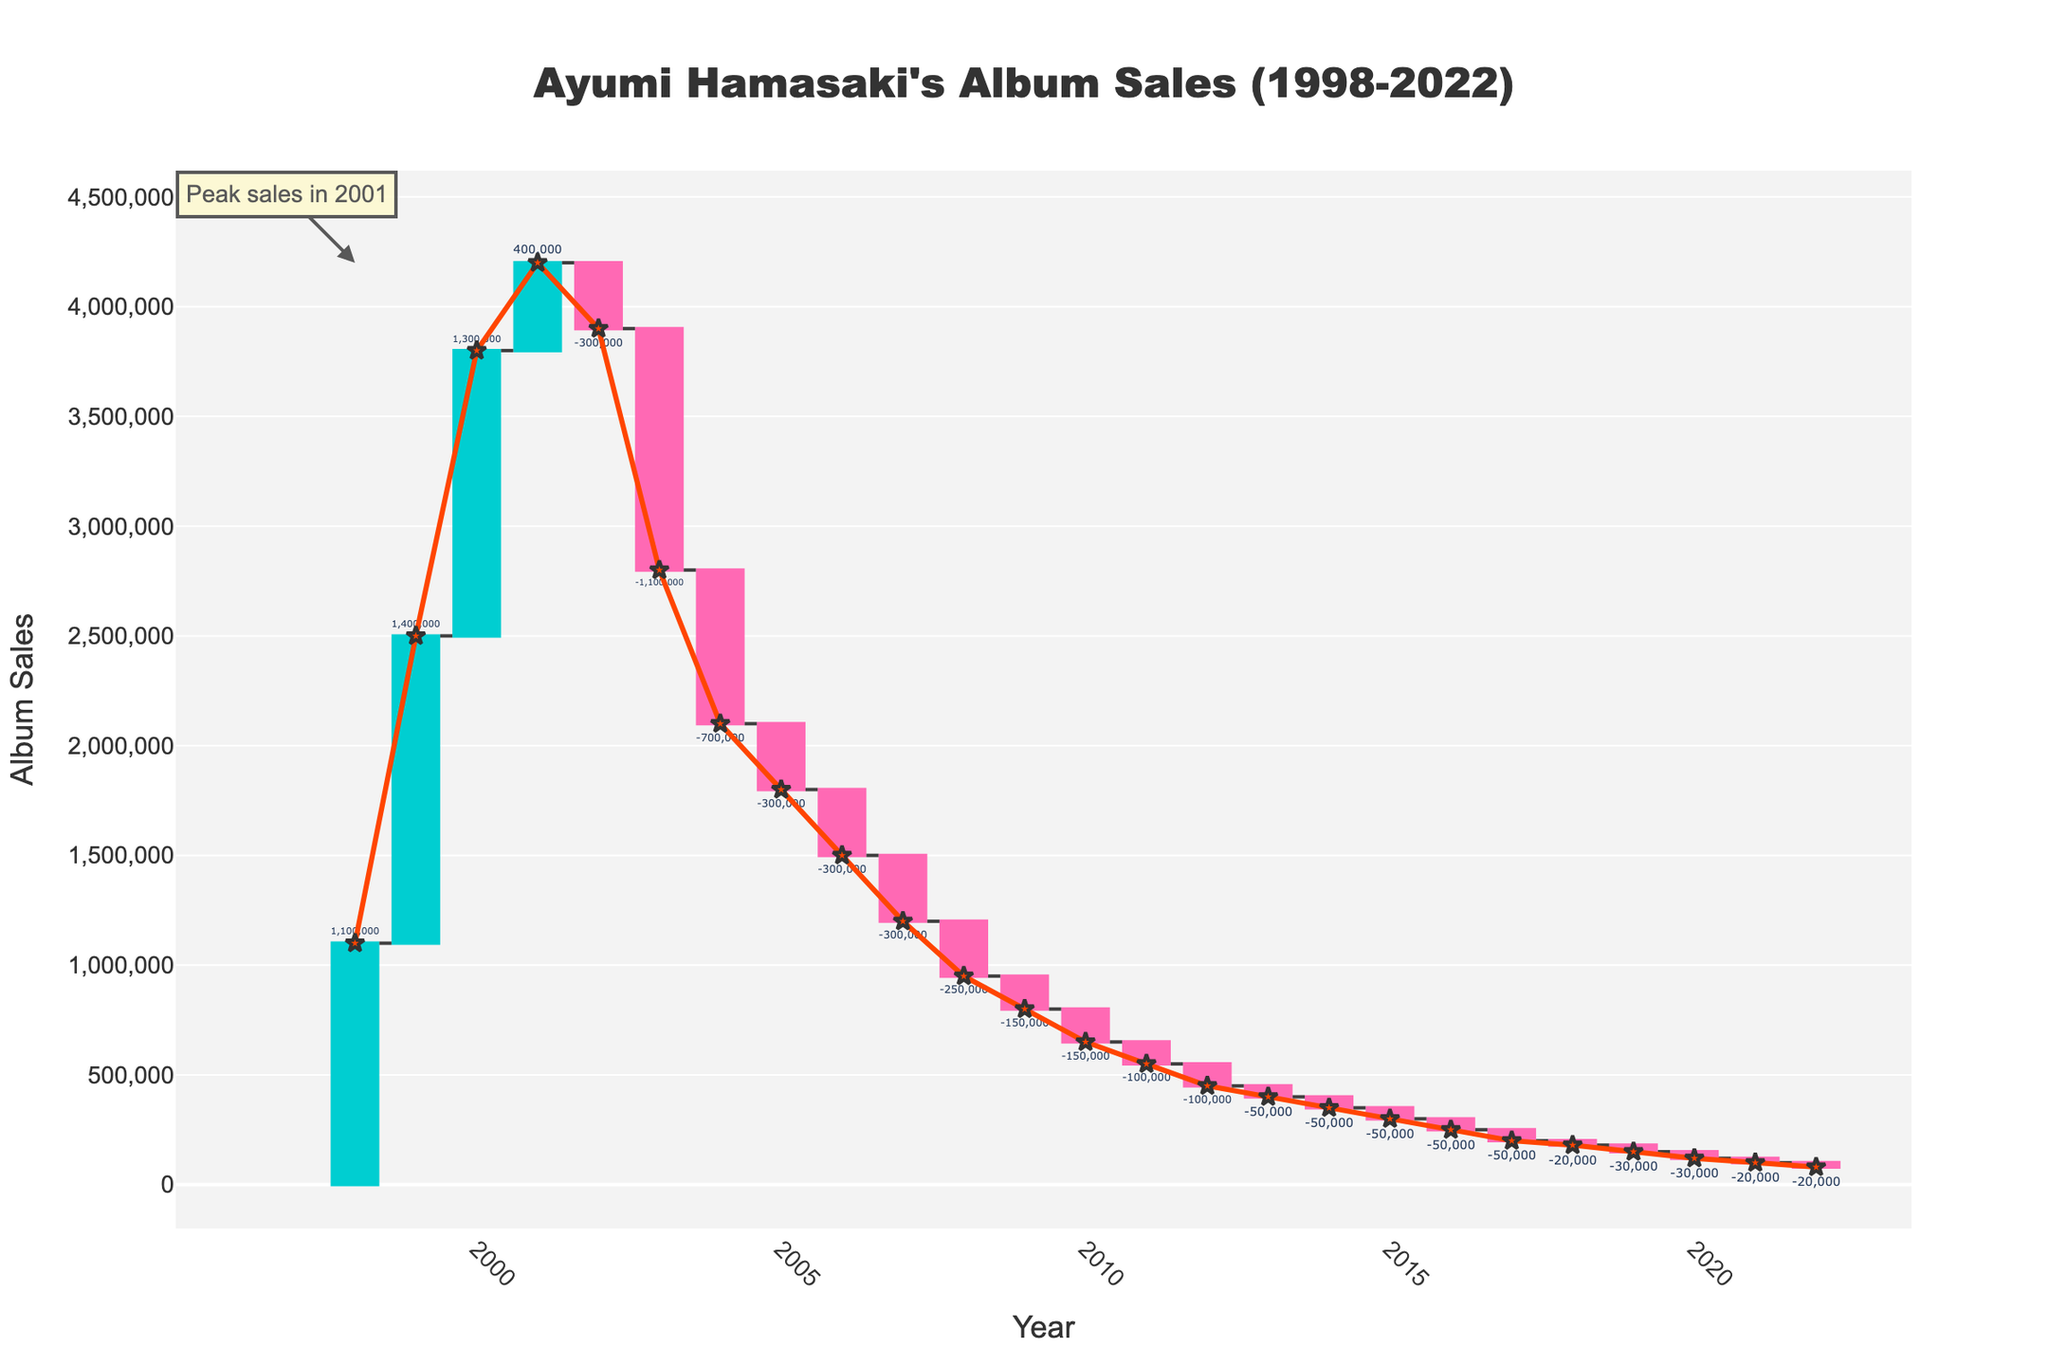what is the title of the waterfall chart? The title is usually positioned at the top of the chart and is visually distinct, making it easy to spot. Here, the title should inform us about the subject and the timeframe.
Answer: "Ayumi Hamasaki's Album Sales (1998-2022)" what is the peak sales year for Ayumi Hamasaki according to the chart? You can identify the peak year by locating the highest value in the chart. An annotation also indicates this peak.
Answer: 2001 How many years does the chart cover? To determine the number of years, count the range from the first year listed on the x-axis to the last year listed.
Answer: 25 years which year showed the largest positive difference in album sales from the previous year? Examine the chart for the largest increase between two consecutive years by comparing the heights of the positive bars.
Answer: 1999 After the peak year, did album sales increase, decrease, or stay the same the following year? Look at the bars corresponding to the years just before and after the peak year. Check whether the bar for the year after the peak is above, below, or at the same level.
Answer: Decrease What are the start and end points of the total sales line over the years? Identify the starting value of the line at the beginning year and its ending value at the final year, marked by lines and points on the chart.
Answer: Start: 1,100,000, End: 80,000 Which year had the lowest album sales? To find this, locate the shortest bar on the chart or the smallest value along the y-axis.
Answer: 2022 What's the sum of album sales during the first three years? To get the sum, add the sales values for the years 1998, 1999, and 2000.
Answer: 7,600,000 How much did album sales decrease from 2001 to 2002? Subtract the album sales of 2002 from 2001 to find the difference.
Answer: 300,000 During which period did the album sales fall most consistently year over year? Identify the longest continuous stretch of decreasing bars to find the period of consistent decline.
Answer: 2007 to 2022 